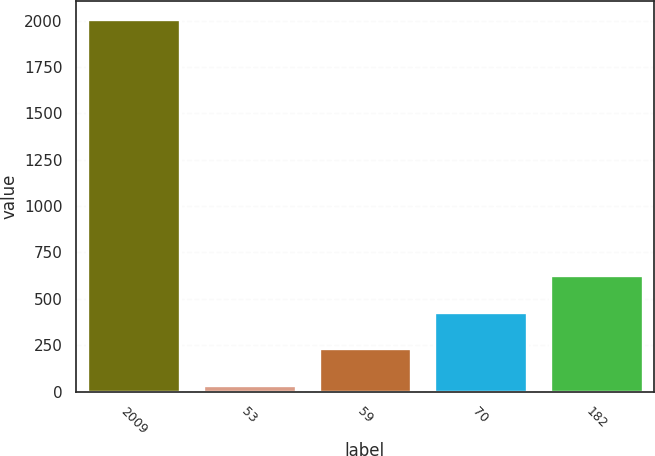Convert chart. <chart><loc_0><loc_0><loc_500><loc_500><bar_chart><fcel>2009<fcel>53<fcel>59<fcel>70<fcel>182<nl><fcel>2007<fcel>37<fcel>234<fcel>431<fcel>628<nl></chart> 